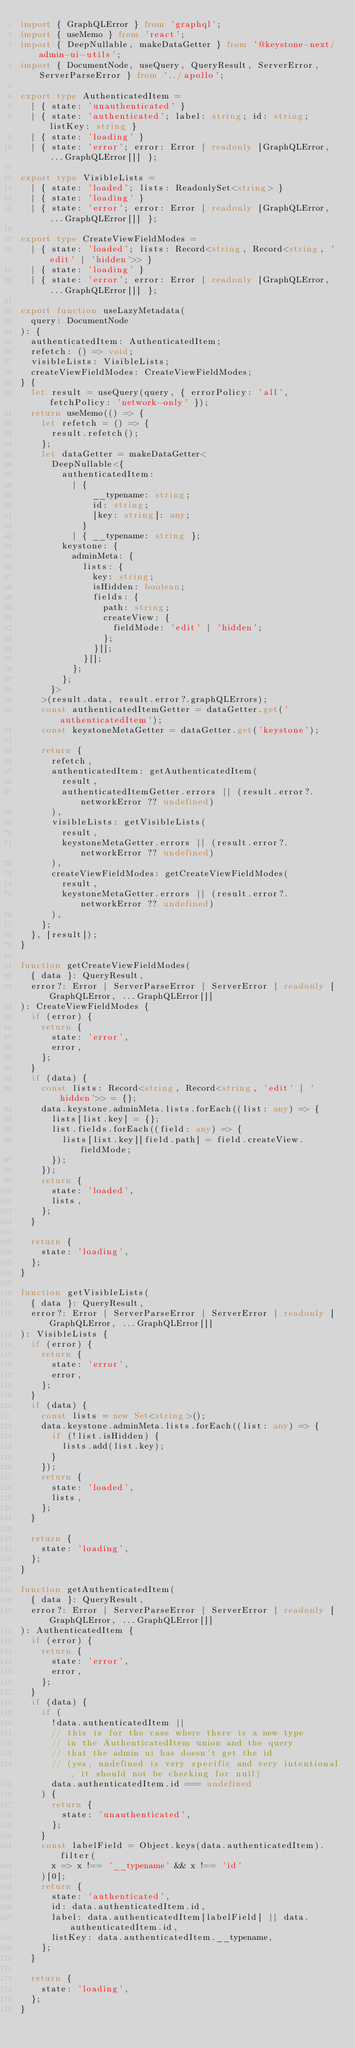Convert code to text. <code><loc_0><loc_0><loc_500><loc_500><_TypeScript_>import { GraphQLError } from 'graphql';
import { useMemo } from 'react';
import { DeepNullable, makeDataGetter } from '@keystone-next/admin-ui-utils';
import { DocumentNode, useQuery, QueryResult, ServerError, ServerParseError } from '../apollo';

export type AuthenticatedItem =
  | { state: 'unauthenticated' }
  | { state: 'authenticated'; label: string; id: string; listKey: string }
  | { state: 'loading' }
  | { state: 'error'; error: Error | readonly [GraphQLError, ...GraphQLError[]] };

export type VisibleLists =
  | { state: 'loaded'; lists: ReadonlySet<string> }
  | { state: 'loading' }
  | { state: 'error'; error: Error | readonly [GraphQLError, ...GraphQLError[]] };

export type CreateViewFieldModes =
  | { state: 'loaded'; lists: Record<string, Record<string, 'edit' | 'hidden'>> }
  | { state: 'loading' }
  | { state: 'error'; error: Error | readonly [GraphQLError, ...GraphQLError[]] };

export function useLazyMetadata(
  query: DocumentNode
): {
  authenticatedItem: AuthenticatedItem;
  refetch: () => void;
  visibleLists: VisibleLists;
  createViewFieldModes: CreateViewFieldModes;
} {
  let result = useQuery(query, { errorPolicy: 'all', fetchPolicy: 'network-only' });
  return useMemo(() => {
    let refetch = () => {
      result.refetch();
    };
    let dataGetter = makeDataGetter<
      DeepNullable<{
        authenticatedItem:
          | {
              __typename: string;
              id: string;
              [key: string]: any;
            }
          | { __typename: string };
        keystone: {
          adminMeta: {
            lists: {
              key: string;
              isHidden: boolean;
              fields: {
                path: string;
                createView: {
                  fieldMode: 'edit' | 'hidden';
                };
              }[];
            }[];
          };
        };
      }>
    >(result.data, result.error?.graphQLErrors);
    const authenticatedItemGetter = dataGetter.get('authenticatedItem');
    const keystoneMetaGetter = dataGetter.get('keystone');

    return {
      refetch,
      authenticatedItem: getAuthenticatedItem(
        result,
        authenticatedItemGetter.errors || (result.error?.networkError ?? undefined)
      ),
      visibleLists: getVisibleLists(
        result,
        keystoneMetaGetter.errors || (result.error?.networkError ?? undefined)
      ),
      createViewFieldModes: getCreateViewFieldModes(
        result,
        keystoneMetaGetter.errors || (result.error?.networkError ?? undefined)
      ),
    };
  }, [result]);
}

function getCreateViewFieldModes(
  { data }: QueryResult,
  error?: Error | ServerParseError | ServerError | readonly [GraphQLError, ...GraphQLError[]]
): CreateViewFieldModes {
  if (error) {
    return {
      state: 'error',
      error,
    };
  }
  if (data) {
    const lists: Record<string, Record<string, 'edit' | 'hidden'>> = {};
    data.keystone.adminMeta.lists.forEach((list: any) => {
      lists[list.key] = {};
      list.fields.forEach((field: any) => {
        lists[list.key][field.path] = field.createView.fieldMode;
      });
    });
    return {
      state: 'loaded',
      lists,
    };
  }

  return {
    state: 'loading',
  };
}

function getVisibleLists(
  { data }: QueryResult,
  error?: Error | ServerParseError | ServerError | readonly [GraphQLError, ...GraphQLError[]]
): VisibleLists {
  if (error) {
    return {
      state: 'error',
      error,
    };
  }
  if (data) {
    const lists = new Set<string>();
    data.keystone.adminMeta.lists.forEach((list: any) => {
      if (!list.isHidden) {
        lists.add(list.key);
      }
    });
    return {
      state: 'loaded',
      lists,
    };
  }

  return {
    state: 'loading',
  };
}

function getAuthenticatedItem(
  { data }: QueryResult,
  error?: Error | ServerParseError | ServerError | readonly [GraphQLError, ...GraphQLError[]]
): AuthenticatedItem {
  if (error) {
    return {
      state: 'error',
      error,
    };
  }
  if (data) {
    if (
      !data.authenticatedItem ||
      // this is for the case where there is a new type
      // in the AuthenticatedItem union and the query
      // that the admin ui has doesn't get the id
      // (yes, undefined is very specific and very intentional, it should not be checking for null)
      data.authenticatedItem.id === undefined
    ) {
      return {
        state: 'unauthenticated',
      };
    }
    const labelField = Object.keys(data.authenticatedItem).filter(
      x => x !== '__typename' && x !== 'id'
    )[0];
    return {
      state: 'authenticated',
      id: data.authenticatedItem.id,
      label: data.authenticatedItem[labelField] || data.authenticatedItem.id,
      listKey: data.authenticatedItem.__typename,
    };
  }

  return {
    state: 'loading',
  };
}
</code> 